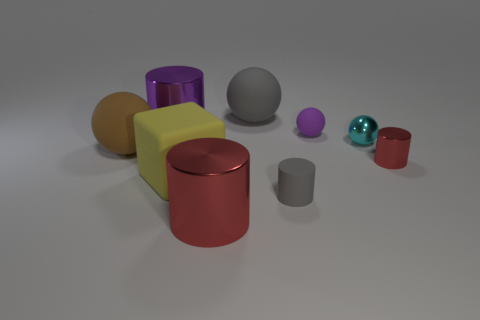Add 1 tiny shiny things. How many objects exist? 10 Subtract all cubes. How many objects are left? 8 Subtract 1 gray cylinders. How many objects are left? 8 Subtract all small cyan metal balls. Subtract all big matte balls. How many objects are left? 6 Add 2 brown matte balls. How many brown matte balls are left? 3 Add 3 big green balls. How many big green balls exist? 3 